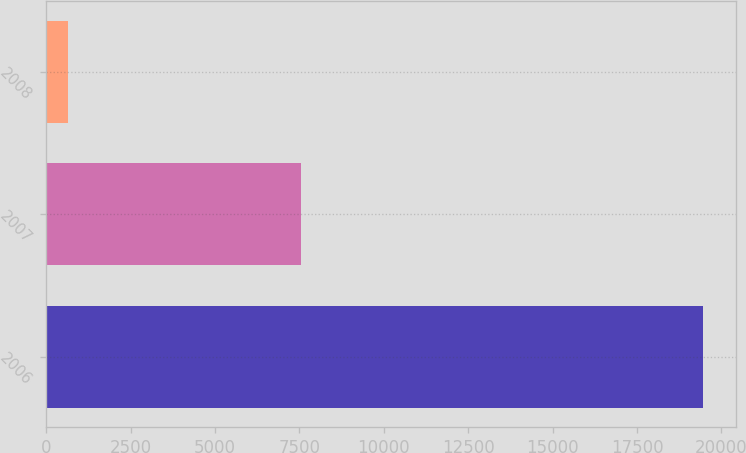Convert chart to OTSL. <chart><loc_0><loc_0><loc_500><loc_500><bar_chart><fcel>2006<fcel>2007<fcel>2008<nl><fcel>19456<fcel>7542<fcel>651<nl></chart> 